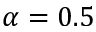Convert formula to latex. <formula><loc_0><loc_0><loc_500><loc_500>\alpha = 0 . 5</formula> 